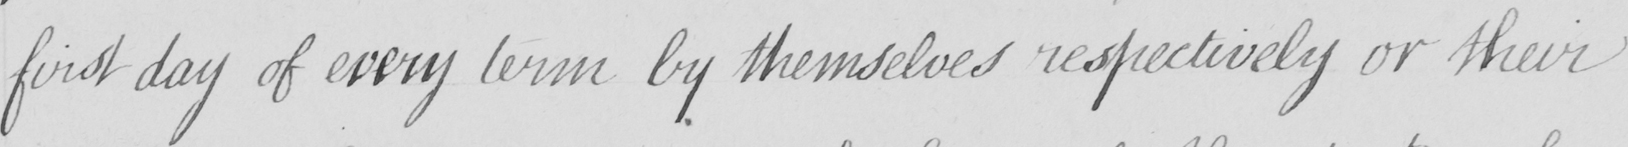Transcribe the text shown in this historical manuscript line. first day of every term by themselves respecttively or their 